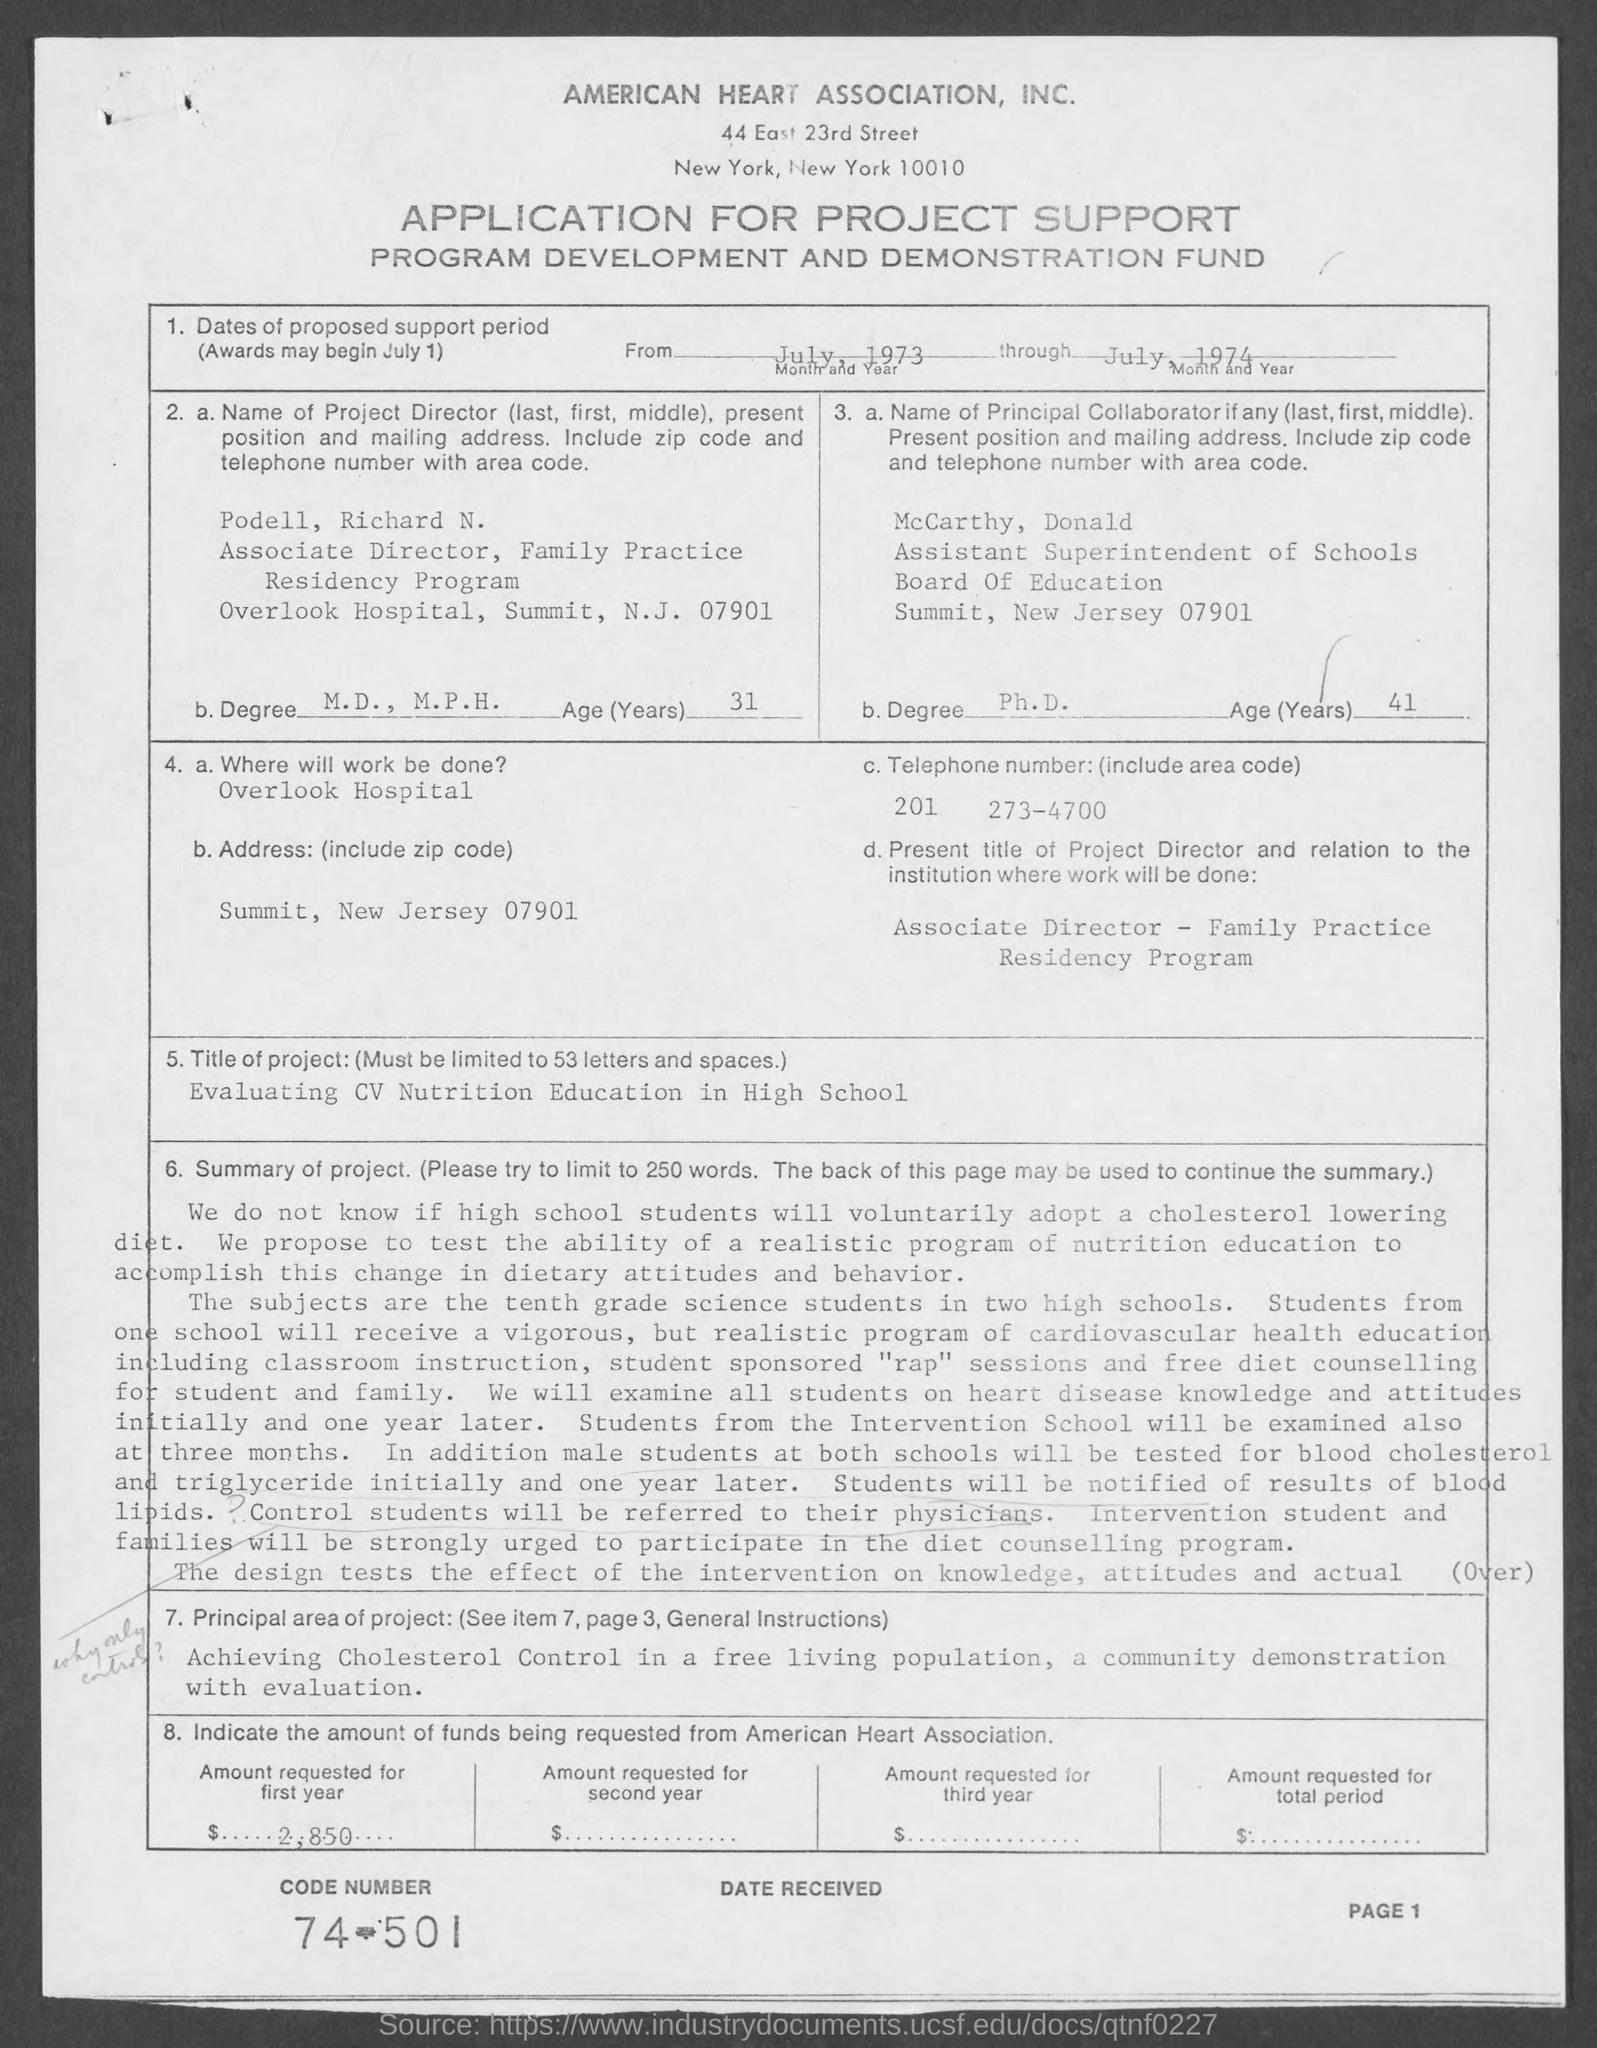What is the name of the association mentioned in the given application ?
Your response must be concise. American heart association , Inc. What are the dates of proposed support period as mentioned in the given page ?
Offer a very short reply. From july , 1973 through july 1974. What is the code number mentioned in the given page ?
Keep it short and to the point. 74-501. What is the telephone number(include area code)mentioned in the given page ?
Your response must be concise. 201 273-4700. What is the age(years) of mccarthy , donald mentioned in the given page ?
Your answer should be very brief. 41. What is the age (years) of podell, richard n. as mentioned in the given page ?
Give a very brief answer. 31. Where will work be done as mentioned in the given page ?
Ensure brevity in your answer.  Overlook hospital. What is the title of the project mentioned in the given page ?
Your answer should be very brief. Evaluating CV Nutrition Education in High School. What is the principal area of project mentioned in the given page ?
Your answer should be very brief. Achieving cholesterol control in a free living population, a community demonstration with evaluation. 